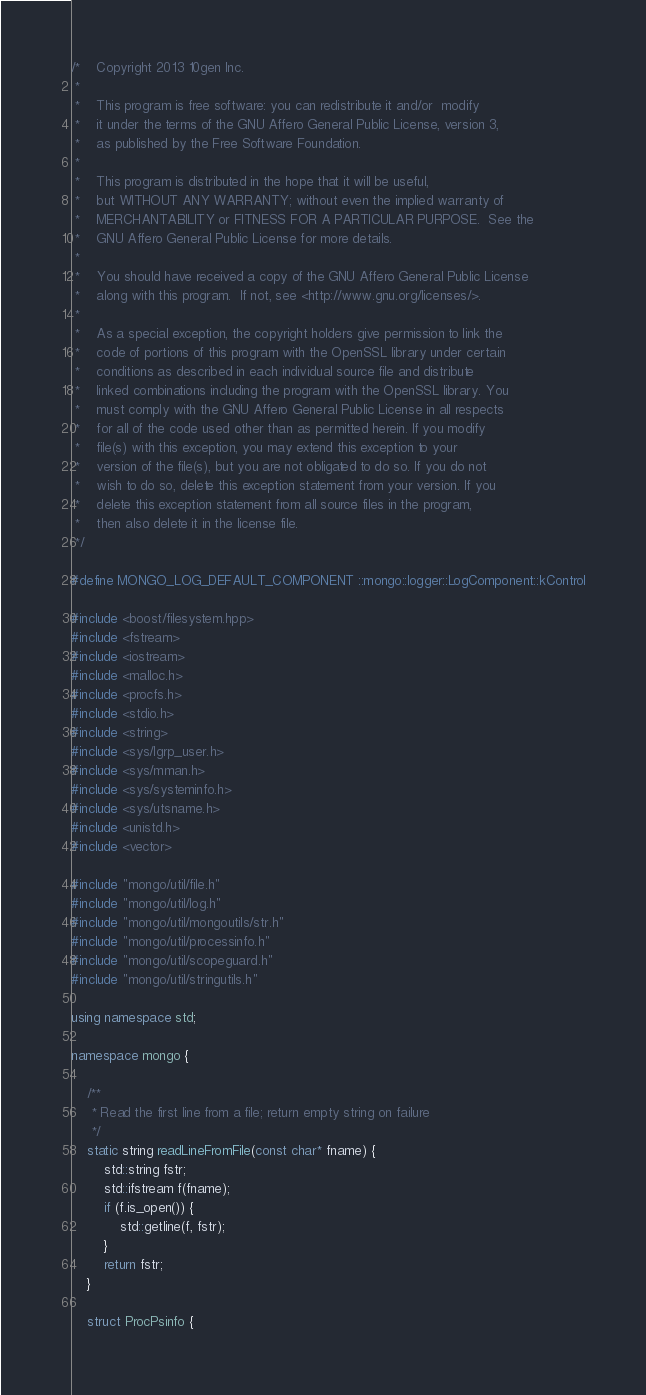<code> <loc_0><loc_0><loc_500><loc_500><_C++_>/*    Copyright 2013 10gen Inc.
 *
 *    This program is free software: you can redistribute it and/or  modify
 *    it under the terms of the GNU Affero General Public License, version 3,
 *    as published by the Free Software Foundation.
 *
 *    This program is distributed in the hope that it will be useful,
 *    but WITHOUT ANY WARRANTY; without even the implied warranty of
 *    MERCHANTABILITY or FITNESS FOR A PARTICULAR PURPOSE.  See the
 *    GNU Affero General Public License for more details.
 *
 *    You should have received a copy of the GNU Affero General Public License
 *    along with this program.  If not, see <http://www.gnu.org/licenses/>.
 *
 *    As a special exception, the copyright holders give permission to link the
 *    code of portions of this program with the OpenSSL library under certain
 *    conditions as described in each individual source file and distribute
 *    linked combinations including the program with the OpenSSL library. You
 *    must comply with the GNU Affero General Public License in all respects
 *    for all of the code used other than as permitted herein. If you modify
 *    file(s) with this exception, you may extend this exception to your
 *    version of the file(s), but you are not obligated to do so. If you do not
 *    wish to do so, delete this exception statement from your version. If you
 *    delete this exception statement from all source files in the program,
 *    then also delete it in the license file.
 */

#define MONGO_LOG_DEFAULT_COMPONENT ::mongo::logger::LogComponent::kControl

#include <boost/filesystem.hpp>
#include <fstream>
#include <iostream>
#include <malloc.h>
#include <procfs.h>
#include <stdio.h>
#include <string>
#include <sys/lgrp_user.h>
#include <sys/mman.h>
#include <sys/systeminfo.h>
#include <sys/utsname.h>
#include <unistd.h>
#include <vector>

#include "mongo/util/file.h"
#include "mongo/util/log.h"
#include "mongo/util/mongoutils/str.h"
#include "mongo/util/processinfo.h"
#include "mongo/util/scopeguard.h"
#include "mongo/util/stringutils.h"

using namespace std;

namespace mongo {

    /**
     * Read the first line from a file; return empty string on failure
     */
    static string readLineFromFile(const char* fname) {
        std::string fstr;
        std::ifstream f(fname);
        if (f.is_open()) {
            std::getline(f, fstr);
        }
        return fstr;
    }

    struct ProcPsinfo {</code> 